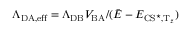<formula> <loc_0><loc_0><loc_500><loc_500>\Lambda _ { D A , e f f } = { \Lambda _ { D B } V _ { B A } } / ( { \bar { E } - E _ { C S ^ { ^ { * } } , { T } _ { z } } } )</formula> 